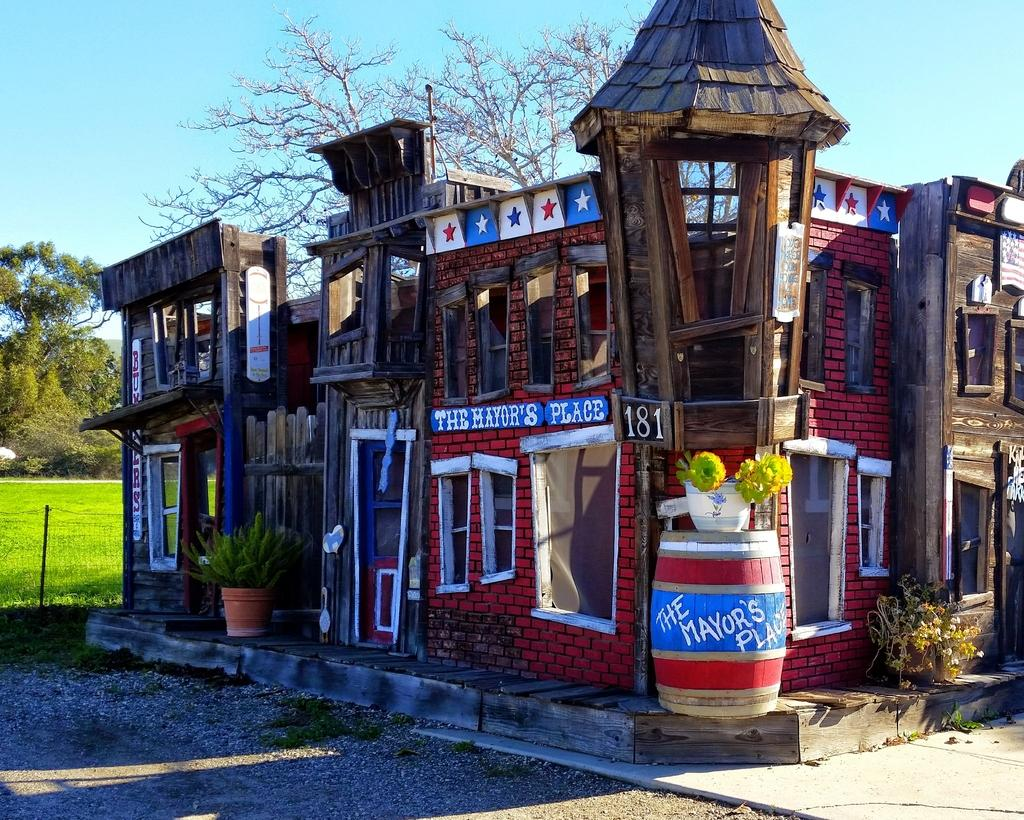What type of structures are visible in the image? There are buildings in the image. What feature do the buildings have? The buildings have glass windows. What type of vegetation is present in the image? There are plants in the image. What is the color of the plants and trees in the image? The plants and trees are green in color. What can be seen in the sky in the image? The sky is blue in color. What type of hat is the snake wearing in the image? There is no snake or hat present in the image. What rule is being enforced by the buildings in the image? The image does not depict any rules being enforced by the buildings. 